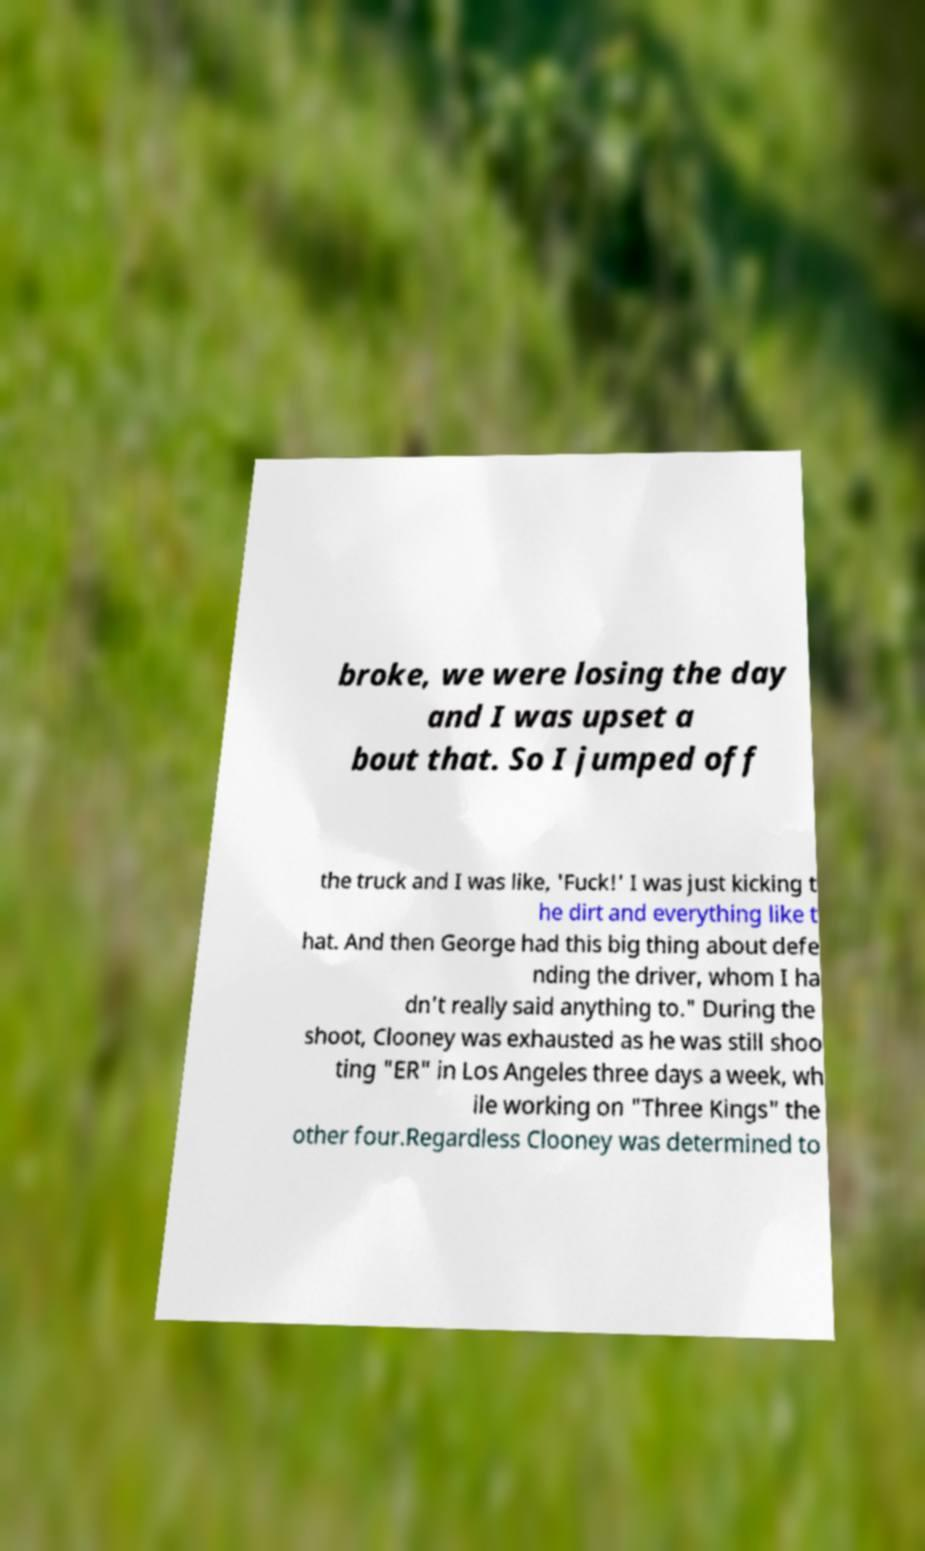There's text embedded in this image that I need extracted. Can you transcribe it verbatim? broke, we were losing the day and I was upset a bout that. So I jumped off the truck and I was like, 'Fuck!' I was just kicking t he dirt and everything like t hat. And then George had this big thing about defe nding the driver, whom I ha dn't really said anything to." During the shoot, Clooney was exhausted as he was still shoo ting "ER" in Los Angeles three days a week, wh ile working on "Three Kings" the other four.Regardless Clooney was determined to 